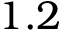Convert formula to latex. <formula><loc_0><loc_0><loc_500><loc_500>1 . 2</formula> 